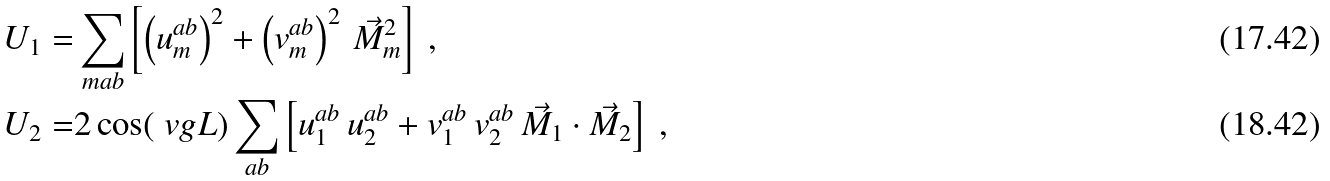Convert formula to latex. <formula><loc_0><loc_0><loc_500><loc_500>U _ { 1 } = & \sum _ { m a b } \left [ \left ( u ^ { a b } _ { m } \right ) ^ { 2 } + \left ( v ^ { a b } _ { m } \right ) ^ { 2 } \, \vec { M } _ { m } ^ { 2 } \right ] \ , \\ U _ { 2 } = & 2 \cos ( \ v g L ) \sum _ { a b } \left [ u ^ { a b } _ { 1 } \, u ^ { a b } _ { 2 } + v ^ { a b } _ { 1 } \, v ^ { a b } _ { 2 } \, \vec { M } _ { 1 } \cdot \vec { M } _ { 2 } \right ] \ ,</formula> 